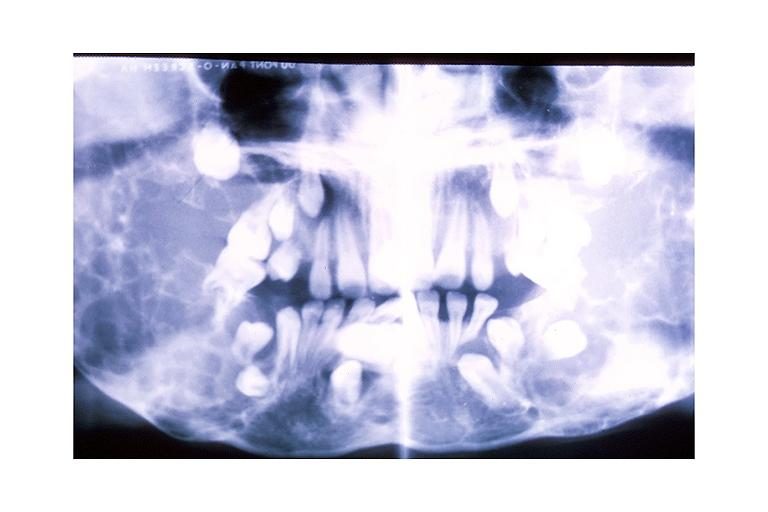s cachexia present?
Answer the question using a single word or phrase. No 